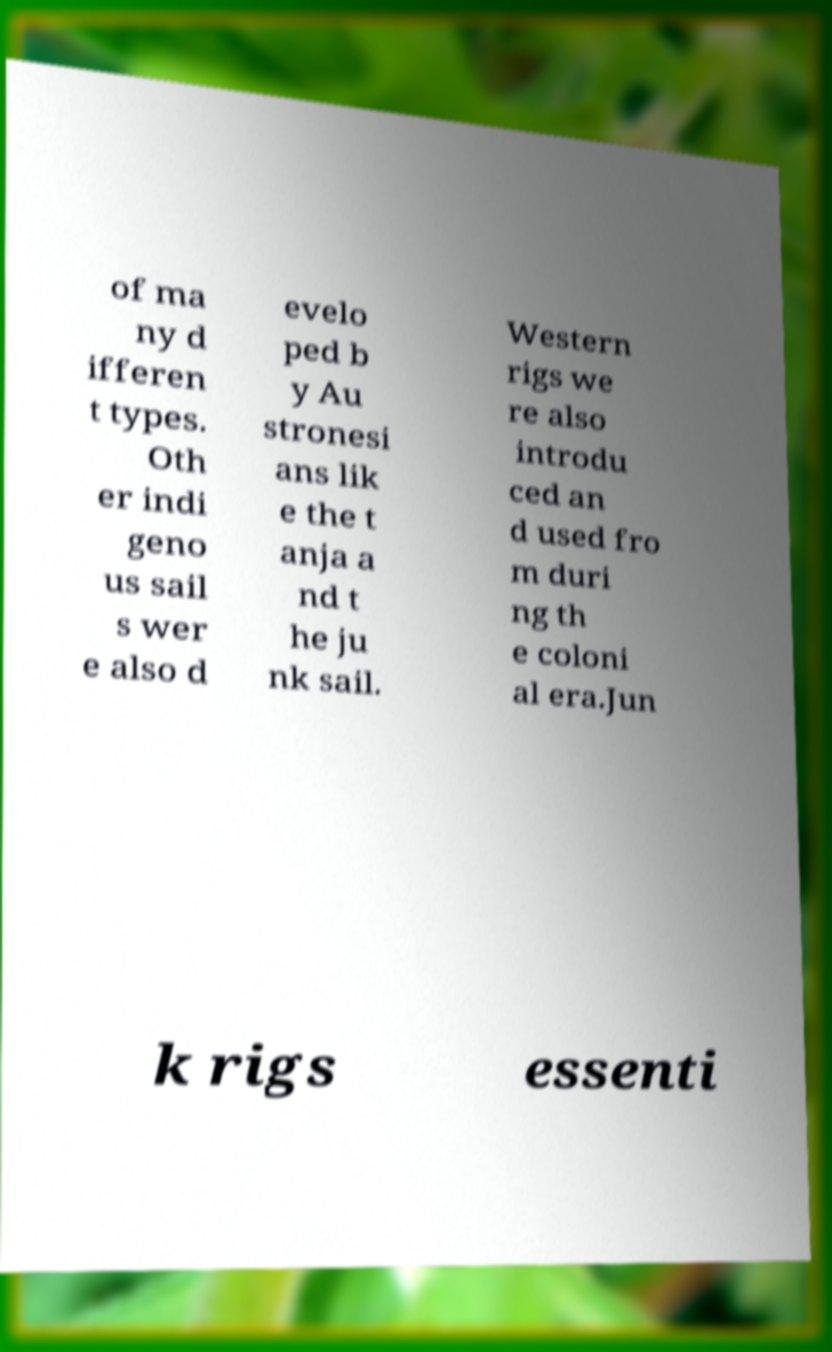Please read and relay the text visible in this image. What does it say? of ma ny d ifferen t types. Oth er indi geno us sail s wer e also d evelo ped b y Au stronesi ans lik e the t anja a nd t he ju nk sail. Western rigs we re also introdu ced an d used fro m duri ng th e coloni al era.Jun k rigs essenti 